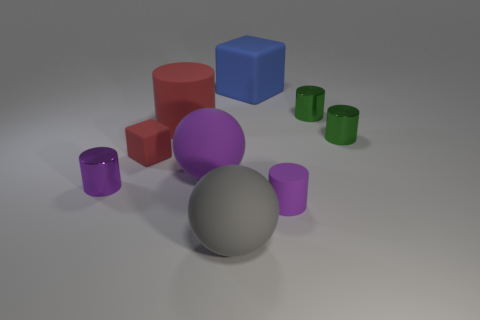Is there a blue object that is to the left of the large rubber object in front of the tiny cylinder left of the large gray rubber thing?
Offer a very short reply. No. What is the material of the other tiny object that is the same shape as the blue rubber object?
Provide a short and direct response. Rubber. Is there anything else that has the same material as the big gray sphere?
Your answer should be very brief. Yes. Are the gray thing and the purple object to the right of the blue matte block made of the same material?
Make the answer very short. Yes. What shape is the small purple thing that is on the left side of the small purple rubber object that is behind the big gray sphere?
Give a very brief answer. Cylinder. How many tiny things are cyan objects or purple cylinders?
Your answer should be compact. 2. How many other small matte objects are the same shape as the gray thing?
Offer a terse response. 0. There is a big gray rubber object; is it the same shape as the tiny purple thing to the right of the big purple ball?
Your answer should be very brief. No. There is a blue thing; what number of large matte things are on the right side of it?
Keep it short and to the point. 0. Is there a yellow object that has the same size as the red rubber block?
Offer a terse response. No. 